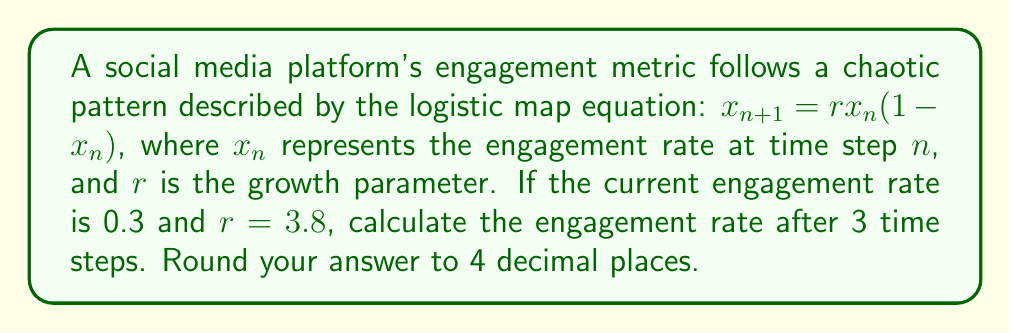Provide a solution to this math problem. To solve this problem, we need to iterate the logistic map equation three times:

1. Given: $x_0 = 0.3$, $r = 3.8$

2. First iteration ($n = 0$ to $n = 1$):
   $$x_1 = 3.8 \cdot 0.3 \cdot (1 - 0.3) = 3.8 \cdot 0.3 \cdot 0.7 = 0.798$$

3. Second iteration ($n = 1$ to $n = 2$):
   $$x_2 = 3.8 \cdot 0.798 \cdot (1 - 0.798) = 3.8 \cdot 0.798 \cdot 0.202 = 0.6131208$$

4. Third iteration ($n = 2$ to $n = 3$):
   $$x_3 = 3.8 \cdot 0.6131208 \cdot (1 - 0.6131208) = 3.8 \cdot 0.6131208 \cdot 0.3868792 = 0.9011175$$

5. Rounding to 4 decimal places:
   $0.9011175 \approx 0.9011$

This demonstrates how the engagement rate evolves chaotically over time, potentially forming a strange attractor in the long-term behavior of the system.
Answer: 0.9011 